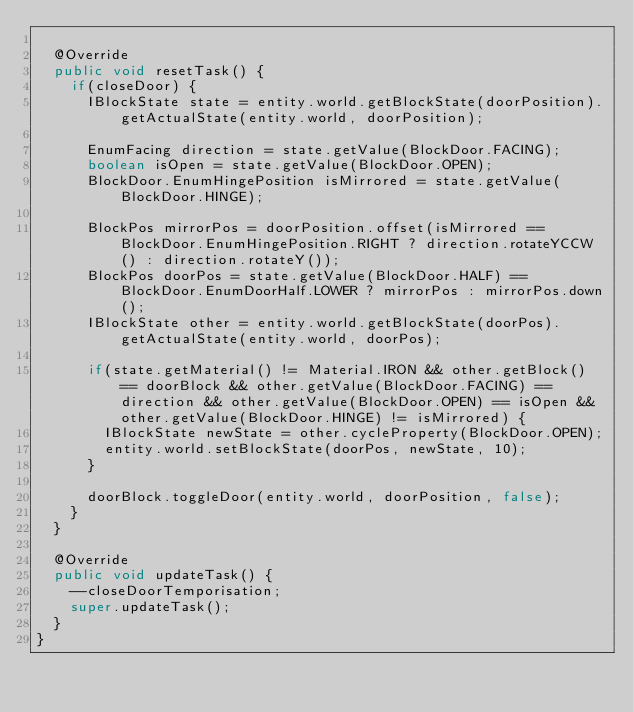Convert code to text. <code><loc_0><loc_0><loc_500><loc_500><_Java_>
	@Override
	public void resetTask() {
		if(closeDoor) {
			IBlockState state = entity.world.getBlockState(doorPosition).getActualState(entity.world, doorPosition);

			EnumFacing direction = state.getValue(BlockDoor.FACING);
			boolean isOpen = state.getValue(BlockDoor.OPEN);
			BlockDoor.EnumHingePosition isMirrored = state.getValue(BlockDoor.HINGE);

			BlockPos mirrorPos = doorPosition.offset(isMirrored == BlockDoor.EnumHingePosition.RIGHT ? direction.rotateYCCW() : direction.rotateY());
			BlockPos doorPos = state.getValue(BlockDoor.HALF) == BlockDoor.EnumDoorHalf.LOWER ? mirrorPos : mirrorPos.down();
			IBlockState other = entity.world.getBlockState(doorPos).getActualState(entity.world, doorPos);

			if(state.getMaterial() != Material.IRON && other.getBlock() == doorBlock && other.getValue(BlockDoor.FACING) == direction && other.getValue(BlockDoor.OPEN) == isOpen && other.getValue(BlockDoor.HINGE) != isMirrored) {
				IBlockState newState = other.cycleProperty(BlockDoor.OPEN);
				entity.world.setBlockState(doorPos, newState, 10);
			}

			doorBlock.toggleDoor(entity.world, doorPosition, false);
		}
	}

	@Override
	public void updateTask() {
		--closeDoorTemporisation;
		super.updateTask();
	}
}</code> 